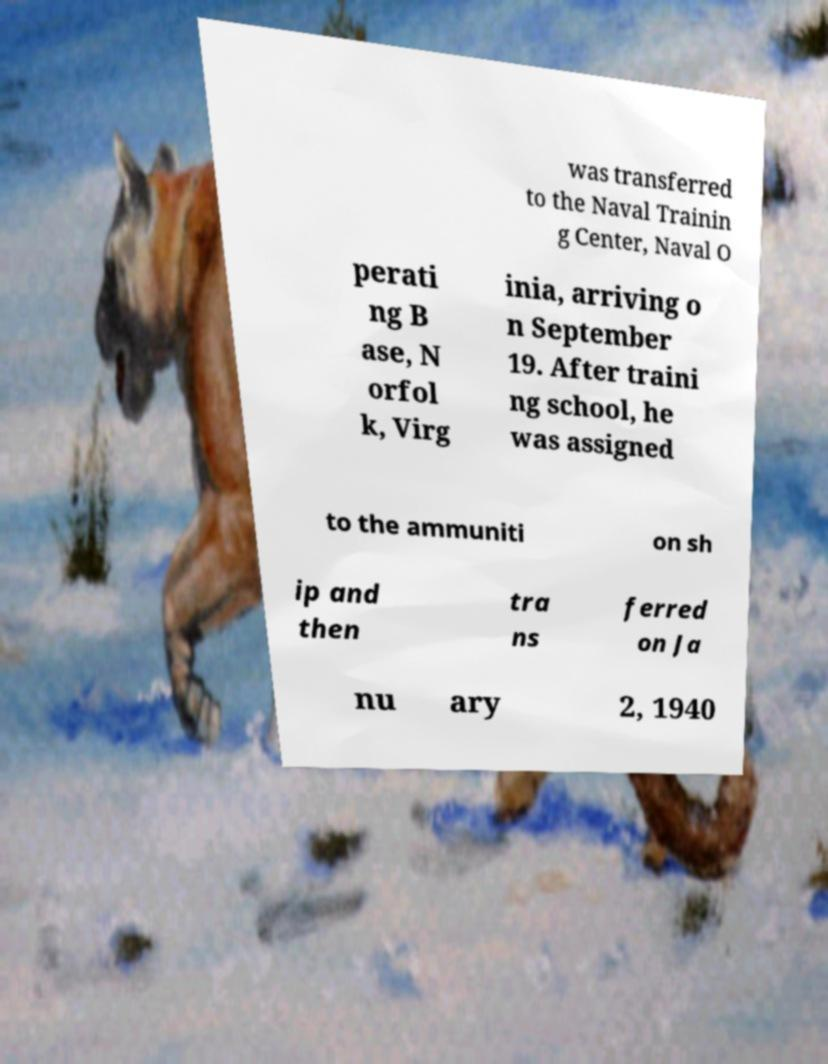Can you accurately transcribe the text from the provided image for me? was transferred to the Naval Trainin g Center, Naval O perati ng B ase, N orfol k, Virg inia, arriving o n September 19. After traini ng school, he was assigned to the ammuniti on sh ip and then tra ns ferred on Ja nu ary 2, 1940 